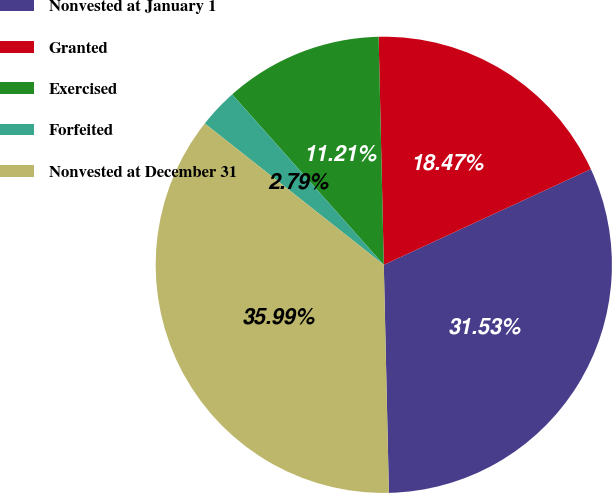Convert chart. <chart><loc_0><loc_0><loc_500><loc_500><pie_chart><fcel>Nonvested at January 1<fcel>Granted<fcel>Exercised<fcel>Forfeited<fcel>Nonvested at December 31<nl><fcel>31.53%<fcel>18.47%<fcel>11.21%<fcel>2.79%<fcel>35.99%<nl></chart> 